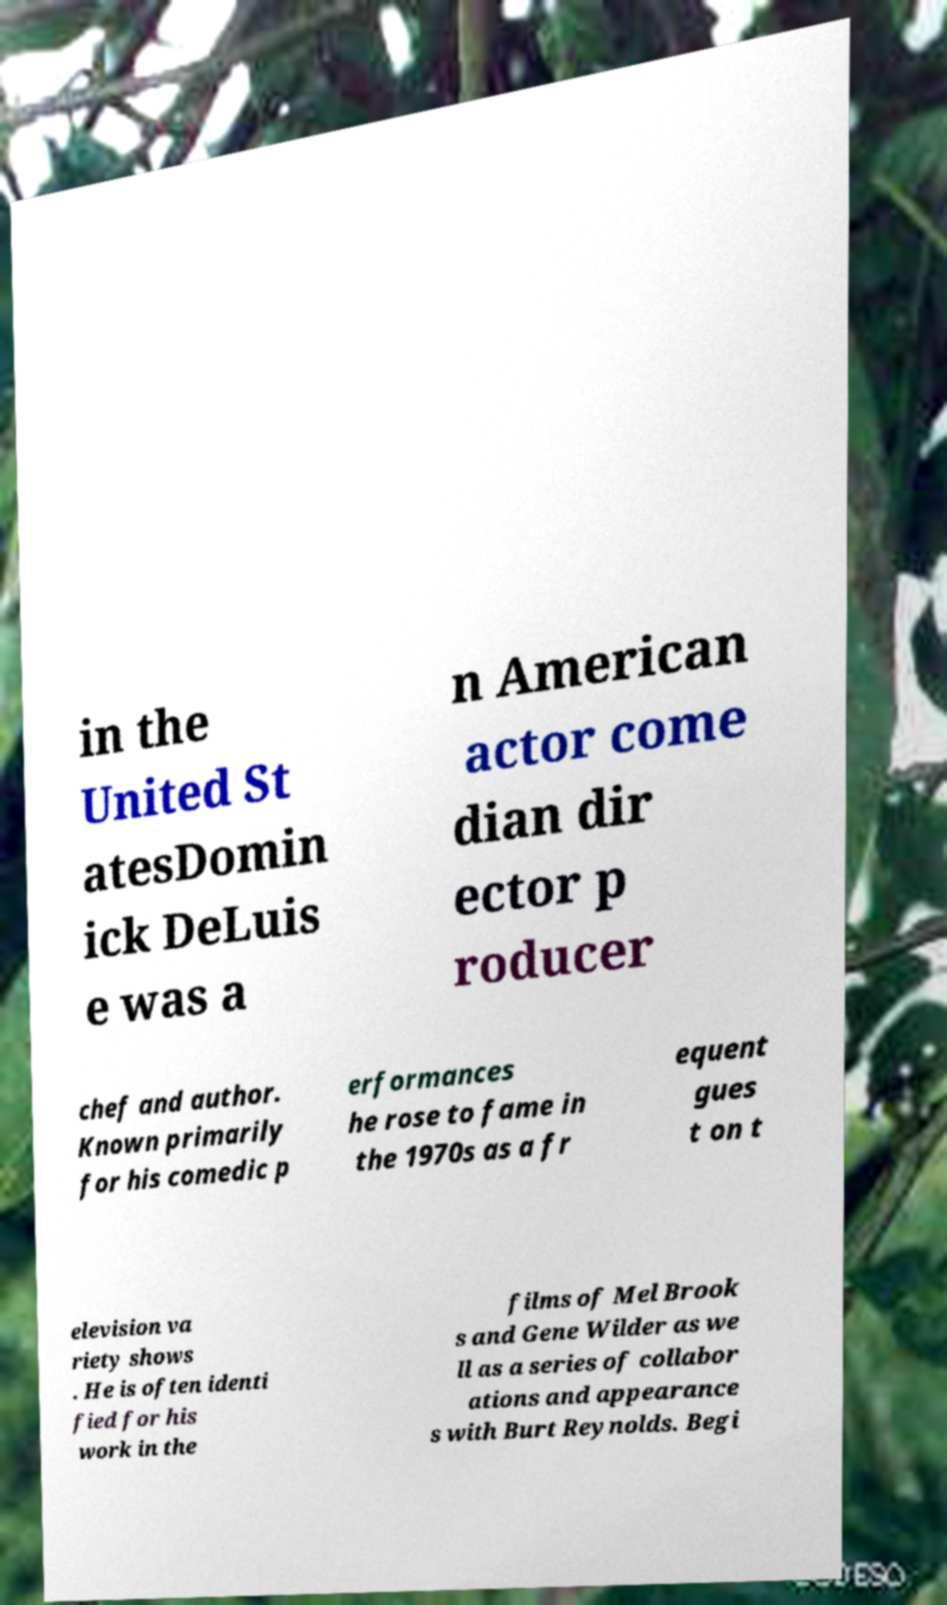Can you accurately transcribe the text from the provided image for me? in the United St atesDomin ick DeLuis e was a n American actor come dian dir ector p roducer chef and author. Known primarily for his comedic p erformances he rose to fame in the 1970s as a fr equent gues t on t elevision va riety shows . He is often identi fied for his work in the films of Mel Brook s and Gene Wilder as we ll as a series of collabor ations and appearance s with Burt Reynolds. Begi 